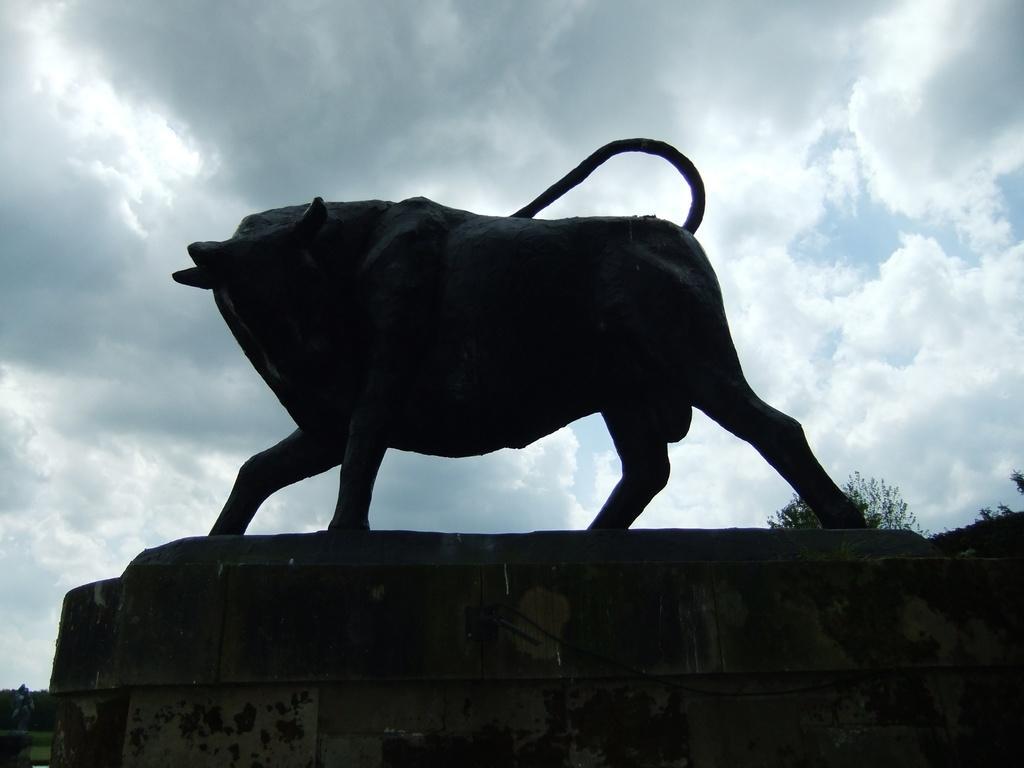How would you summarize this image in a sentence or two? We can see sculpture of an animal on the platform. In the background we can see trees and sky with clouds. 